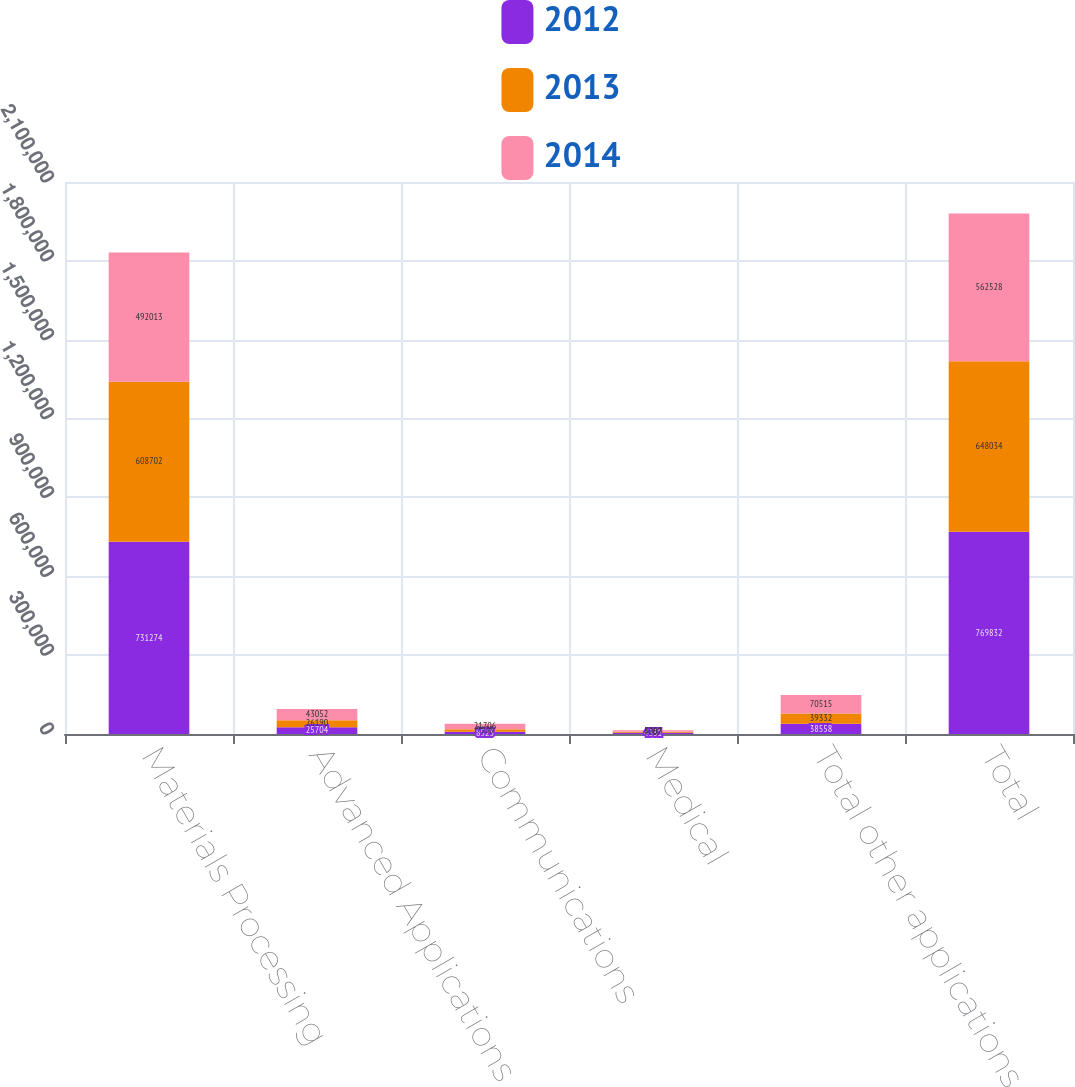<chart> <loc_0><loc_0><loc_500><loc_500><stacked_bar_chart><ecel><fcel>Materials Processing<fcel>Advanced Applications<fcel>Communications<fcel>Medical<fcel>Total other applications<fcel>Total<nl><fcel>2012<fcel>731274<fcel>25704<fcel>8523<fcel>4331<fcel>38558<fcel>769832<nl><fcel>2013<fcel>608702<fcel>26190<fcel>9135<fcel>4007<fcel>39332<fcel>648034<nl><fcel>2014<fcel>492013<fcel>43052<fcel>21706<fcel>5757<fcel>70515<fcel>562528<nl></chart> 